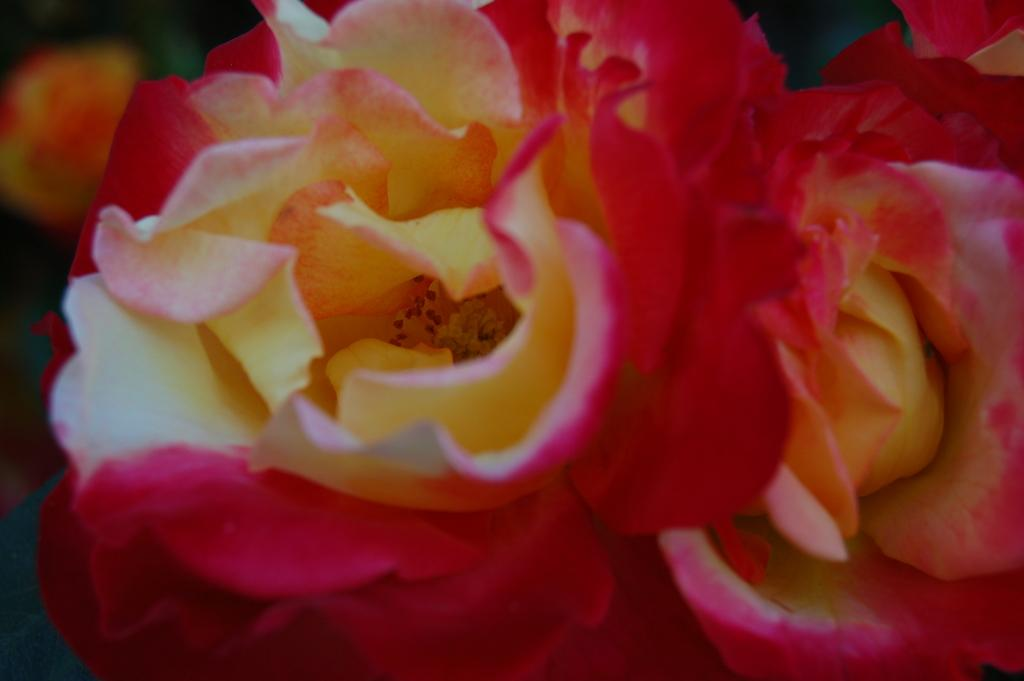What type of plants can be seen in the image? There are flowers in the image. How many oranges are hanging from the flowers in the image? There are no oranges present in the image; it features flowers only. What type of force is being applied to the flowers in the image? There is no force being applied to the flowers in the image; they are simply depicted as they are. 